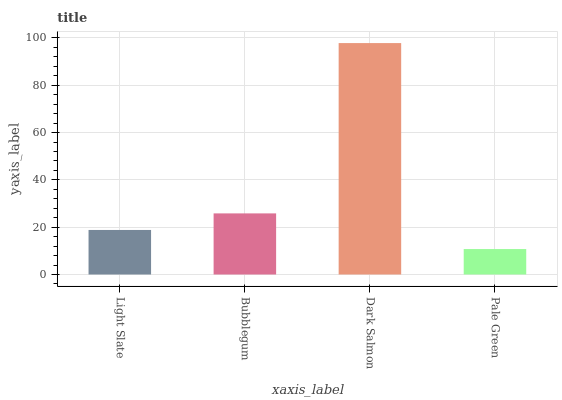Is Pale Green the minimum?
Answer yes or no. Yes. Is Dark Salmon the maximum?
Answer yes or no. Yes. Is Bubblegum the minimum?
Answer yes or no. No. Is Bubblegum the maximum?
Answer yes or no. No. Is Bubblegum greater than Light Slate?
Answer yes or no. Yes. Is Light Slate less than Bubblegum?
Answer yes or no. Yes. Is Light Slate greater than Bubblegum?
Answer yes or no. No. Is Bubblegum less than Light Slate?
Answer yes or no. No. Is Bubblegum the high median?
Answer yes or no. Yes. Is Light Slate the low median?
Answer yes or no. Yes. Is Pale Green the high median?
Answer yes or no. No. Is Pale Green the low median?
Answer yes or no. No. 